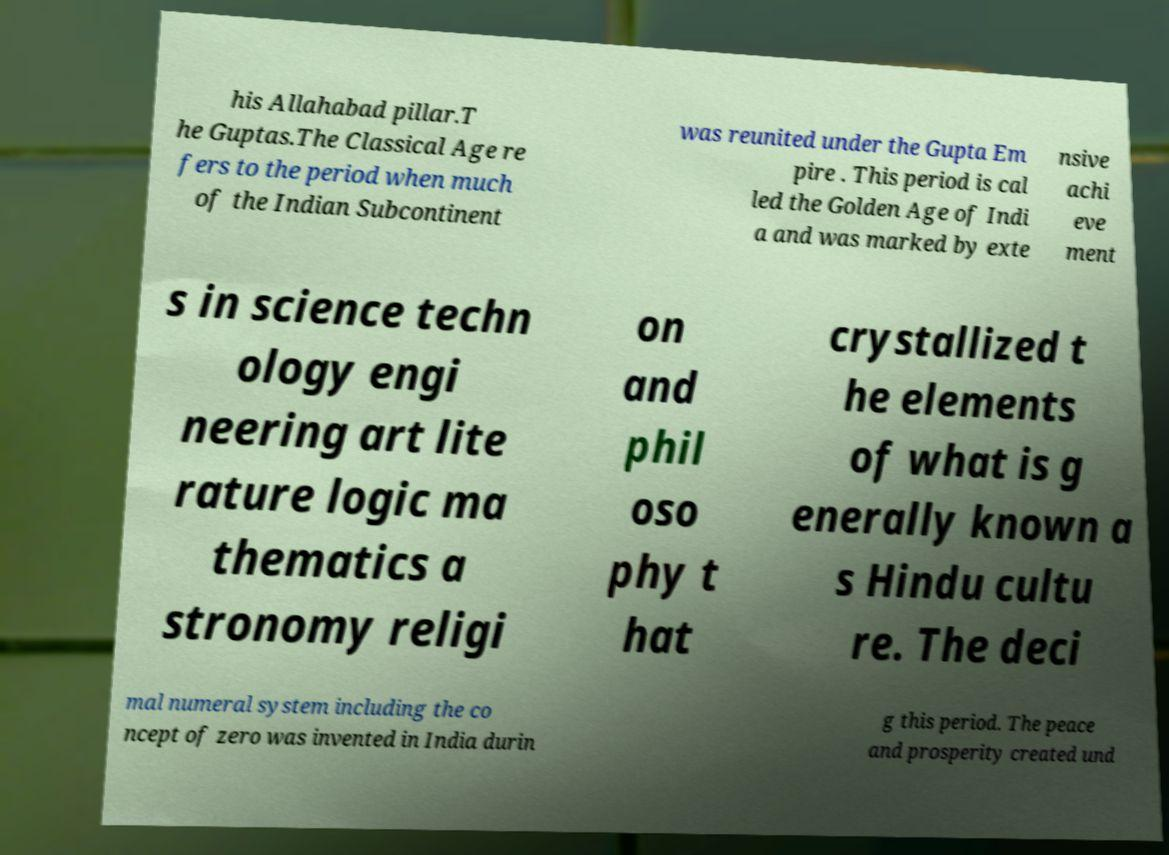Please read and relay the text visible in this image. What does it say? his Allahabad pillar.T he Guptas.The Classical Age re fers to the period when much of the Indian Subcontinent was reunited under the Gupta Em pire . This period is cal led the Golden Age of Indi a and was marked by exte nsive achi eve ment s in science techn ology engi neering art lite rature logic ma thematics a stronomy religi on and phil oso phy t hat crystallized t he elements of what is g enerally known a s Hindu cultu re. The deci mal numeral system including the co ncept of zero was invented in India durin g this period. The peace and prosperity created und 